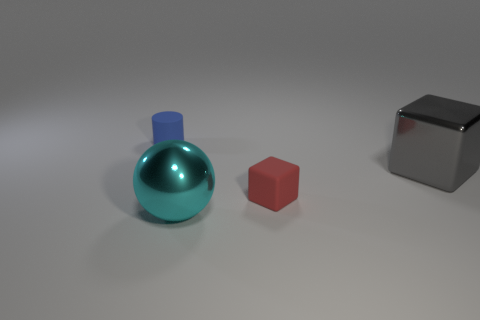Are there more cylinders behind the blue rubber object than blue rubber cylinders that are to the right of the big cyan shiny thing?
Give a very brief answer. No. What is the material of the big gray object that is the same shape as the red matte object?
Keep it short and to the point. Metal. Do the large object that is on the left side of the large gray metal block and the matte thing behind the big gray block have the same color?
Provide a succinct answer. No. What is the shape of the cyan thing?
Your answer should be very brief. Sphere. Are there more blue objects that are in front of the blue matte object than yellow matte balls?
Your response must be concise. No. The thing that is left of the big cyan object has what shape?
Make the answer very short. Cylinder. How many other objects are the same shape as the tiny blue rubber thing?
Your answer should be very brief. 0. Do the small object in front of the small blue cylinder and the gray block have the same material?
Ensure brevity in your answer.  No. Are there an equal number of big cyan metallic spheres that are on the right side of the small block and small matte cylinders to the left of the gray cube?
Keep it short and to the point. No. What size is the thing that is on the left side of the big cyan metal object?
Your answer should be compact. Small. 